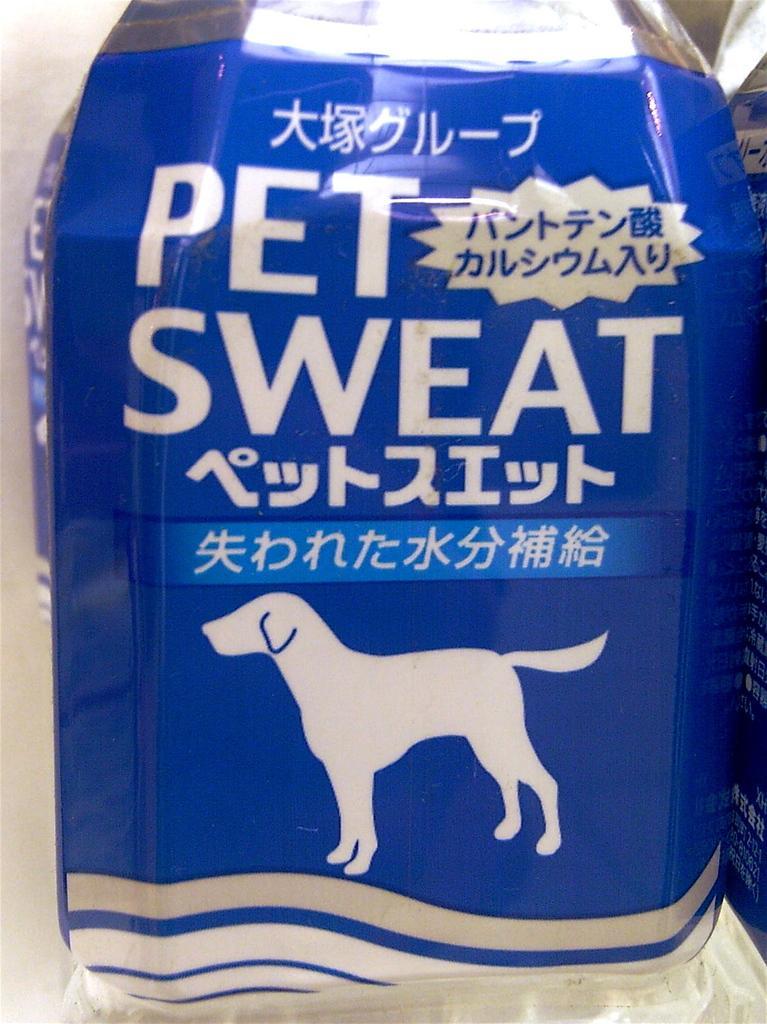In one or two sentences, can you explain what this image depicts? In this image we can see a container with some text on it which is placed on the surface. 